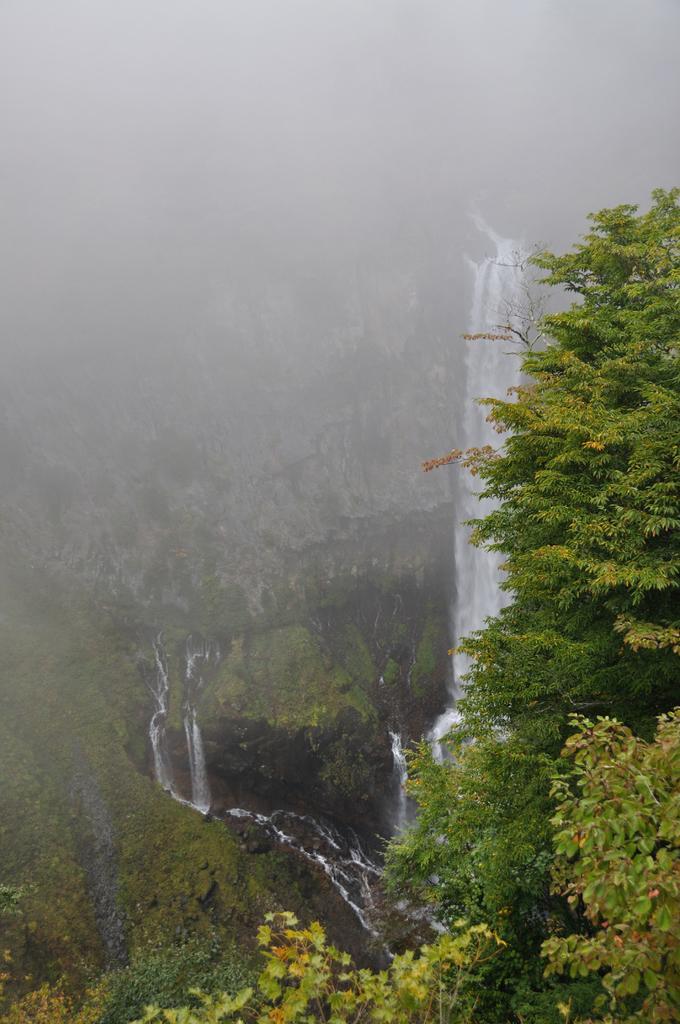Describe this image in one or two sentences. In this image in the background there is a water fall and mountains, and in the foreground there are some trees. 